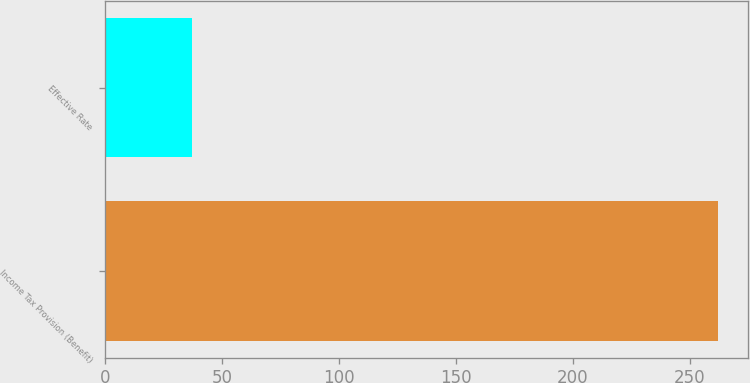Convert chart. <chart><loc_0><loc_0><loc_500><loc_500><bar_chart><fcel>Income Tax Provision (Benefit)<fcel>Effective Rate<nl><fcel>262<fcel>37<nl></chart> 